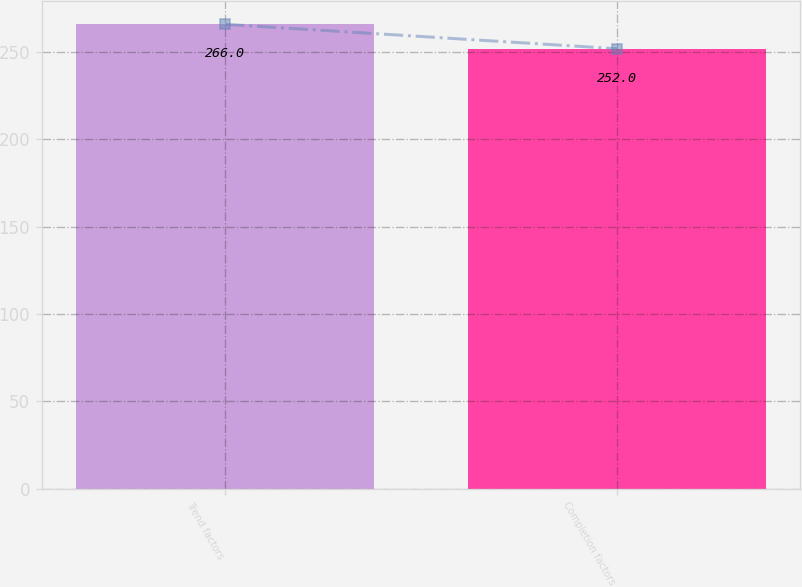Convert chart. <chart><loc_0><loc_0><loc_500><loc_500><bar_chart><fcel>Trend factors<fcel>Completion factors<nl><fcel>266<fcel>252<nl></chart> 